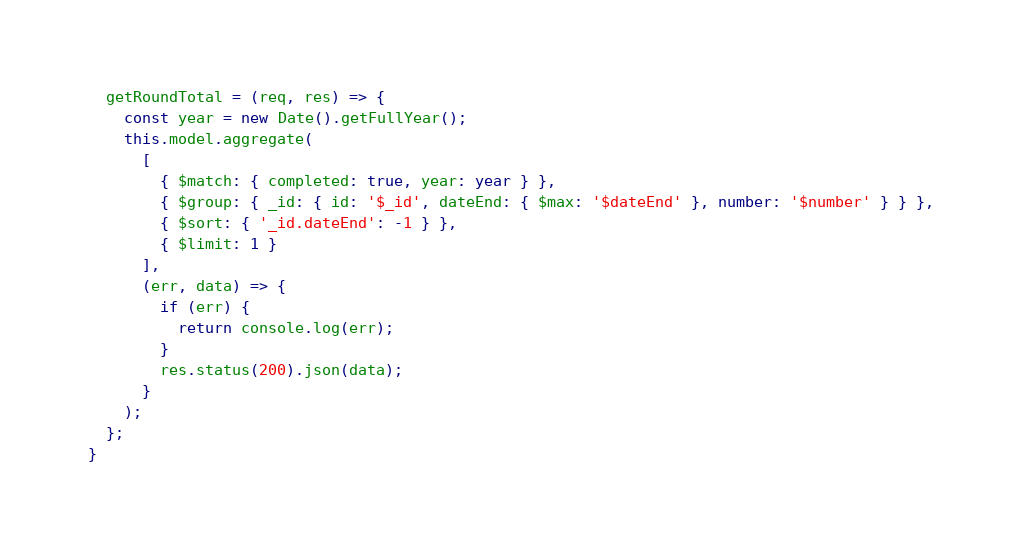Convert code to text. <code><loc_0><loc_0><loc_500><loc_500><_TypeScript_>
  getRoundTotal = (req, res) => {
    const year = new Date().getFullYear();
    this.model.aggregate(
      [
        { $match: { completed: true, year: year } },
        { $group: { _id: { id: '$_id', dateEnd: { $max: '$dateEnd' }, number: '$number' } } },
        { $sort: { '_id.dateEnd': -1 } },
        { $limit: 1 }
      ],
      (err, data) => {
        if (err) {
          return console.log(err);
        }
        res.status(200).json(data);
      }
    );
  };
}
</code> 